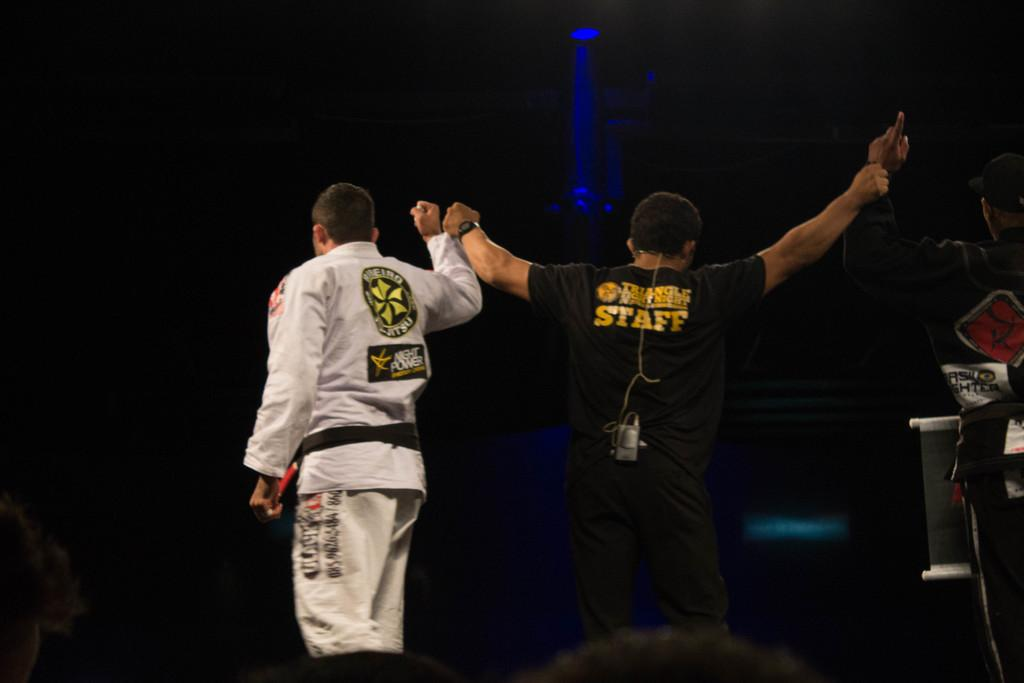<image>
Offer a succinct explanation of the picture presented. a man with the word staff on his back 